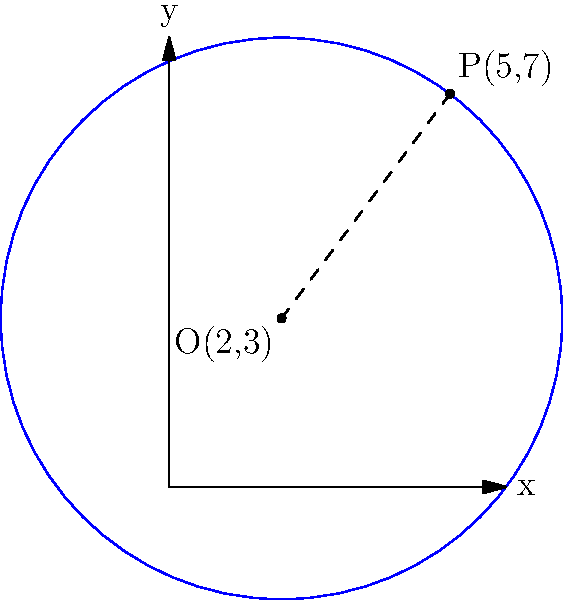As a passionate donor interested in improving user experience, you've been asked to review a new interactive geometry tool. The tool presents a circle with center O(2,3) and a point P(5,7) on its circumference. What is the equation of this circle? Let's approach this step-by-step:

1) The general equation of a circle is $$(x-h)^2 + (y-k)^2 = r^2$$
   where (h,k) is the center and r is the radius.

2) We're given the center O(2,3), so h=2 and k=3.

3) To find the radius, we need to calculate the distance between the center O(2,3) and the point P(5,7) on the circumference.

4) We can use the distance formula:
   $$r = \sqrt{(x_2-x_1)^2 + (y_2-y_1)^2}$$
   $$r = \sqrt{(5-2)^2 + (7-3)^2}$$
   $$r = \sqrt{3^2 + 4^2}$$
   $$r = \sqrt{9 + 16} = \sqrt{25} = 5$$

5) Now we have all the components to write the equation:
   $$(x-2)^2 + (y-3)^2 = 5^2$$

6) Simplifying:
   $$(x-2)^2 + (y-3)^2 = 25$$

This is the equation of the circle.
Answer: $(x-2)^2 + (y-3)^2 = 25$ 